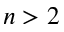Convert formula to latex. <formula><loc_0><loc_0><loc_500><loc_500>n > 2</formula> 